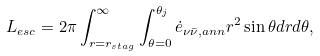<formula> <loc_0><loc_0><loc_500><loc_500>L _ { e s c } = 2 \pi \int _ { r = r _ { s t a g } } ^ { \infty } \int _ { \theta = 0 } ^ { \theta _ { j } } \dot { e } _ { \nu \bar { \nu } , a n n } r ^ { 2 } \sin { \theta } d r d \theta ,</formula> 